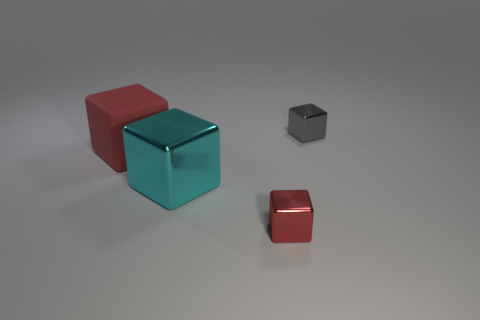Subtract all red cubes. How many were subtracted if there are1red cubes left? 1 Subtract all rubber cubes. How many cubes are left? 3 Subtract all brown spheres. How many red cubes are left? 2 Subtract all gray blocks. How many blocks are left? 3 Subtract 2 cubes. How many cubes are left? 2 Add 1 tiny green metallic balls. How many objects exist? 5 Subtract all blue cubes. Subtract all purple cylinders. How many cubes are left? 4 Subtract all big gray metal blocks. Subtract all red things. How many objects are left? 2 Add 2 small gray shiny blocks. How many small gray shiny blocks are left? 3 Add 1 gray metallic things. How many gray metallic things exist? 2 